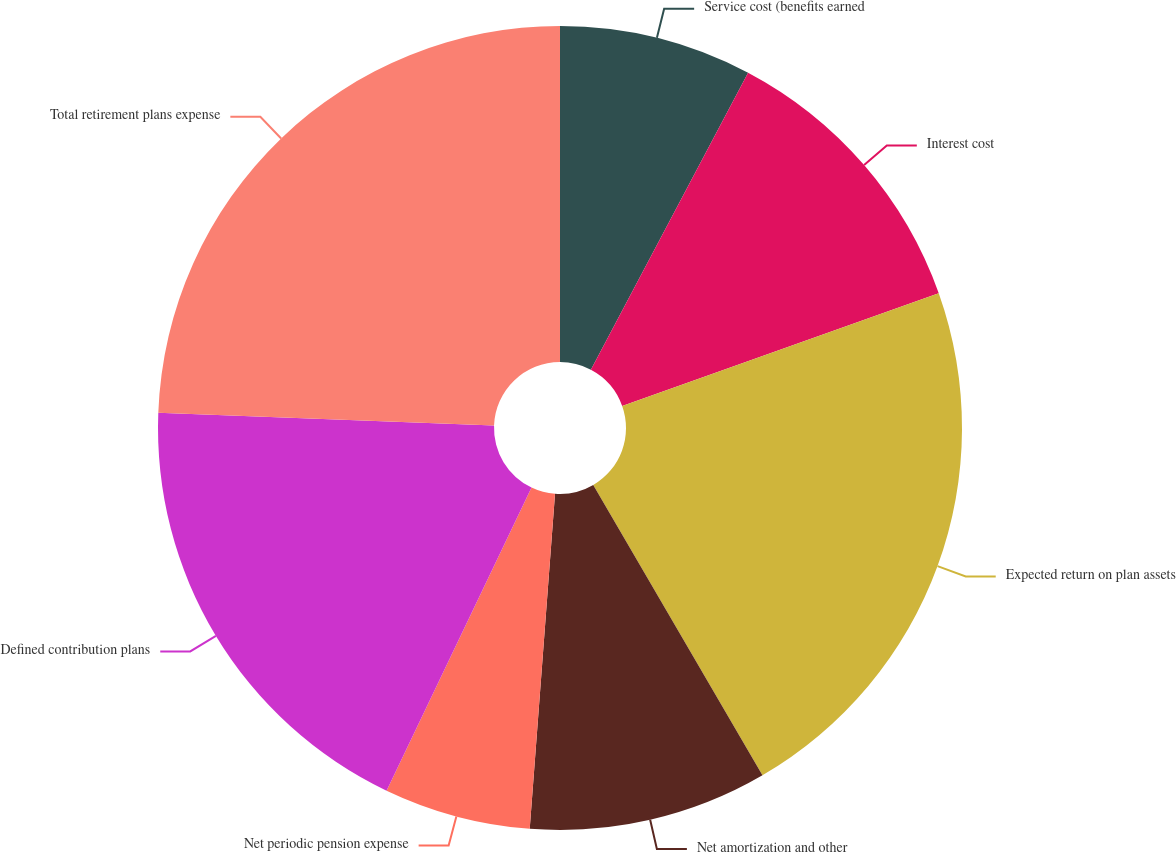Convert chart to OTSL. <chart><loc_0><loc_0><loc_500><loc_500><pie_chart><fcel>Service cost (benefits earned<fcel>Interest cost<fcel>Expected return on plan assets<fcel>Net amortization and other<fcel>Net periodic pension expense<fcel>Defined contribution plans<fcel>Total retirement plans expense<nl><fcel>7.75%<fcel>11.81%<fcel>22.04%<fcel>9.6%<fcel>5.9%<fcel>18.5%<fcel>24.4%<nl></chart> 